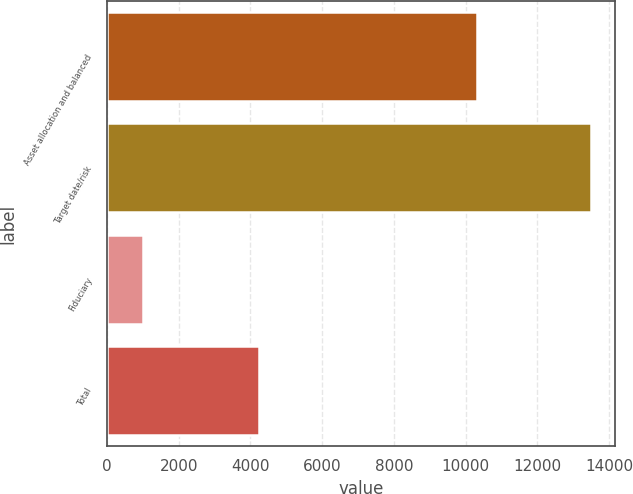Convert chart. <chart><loc_0><loc_0><loc_500><loc_500><bar_chart><fcel>Asset allocation and balanced<fcel>Target date/risk<fcel>Fiduciary<fcel>Total<nl><fcel>10332<fcel>13500<fcel>998<fcel>4227<nl></chart> 